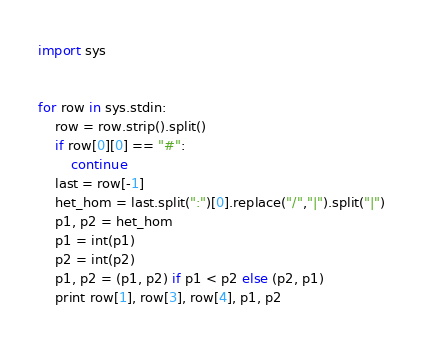<code> <loc_0><loc_0><loc_500><loc_500><_Python_>import sys


for row in sys.stdin:
    row = row.strip().split()
    if row[0][0] == "#":
        continue
    last = row[-1]
    het_hom = last.split(":")[0].replace("/","|").split("|")
    p1, p2 = het_hom
    p1 = int(p1)
    p2 = int(p2)
    p1, p2 = (p1, p2) if p1 < p2 else (p2, p1)
    print row[1], row[3], row[4], p1, p2
</code> 